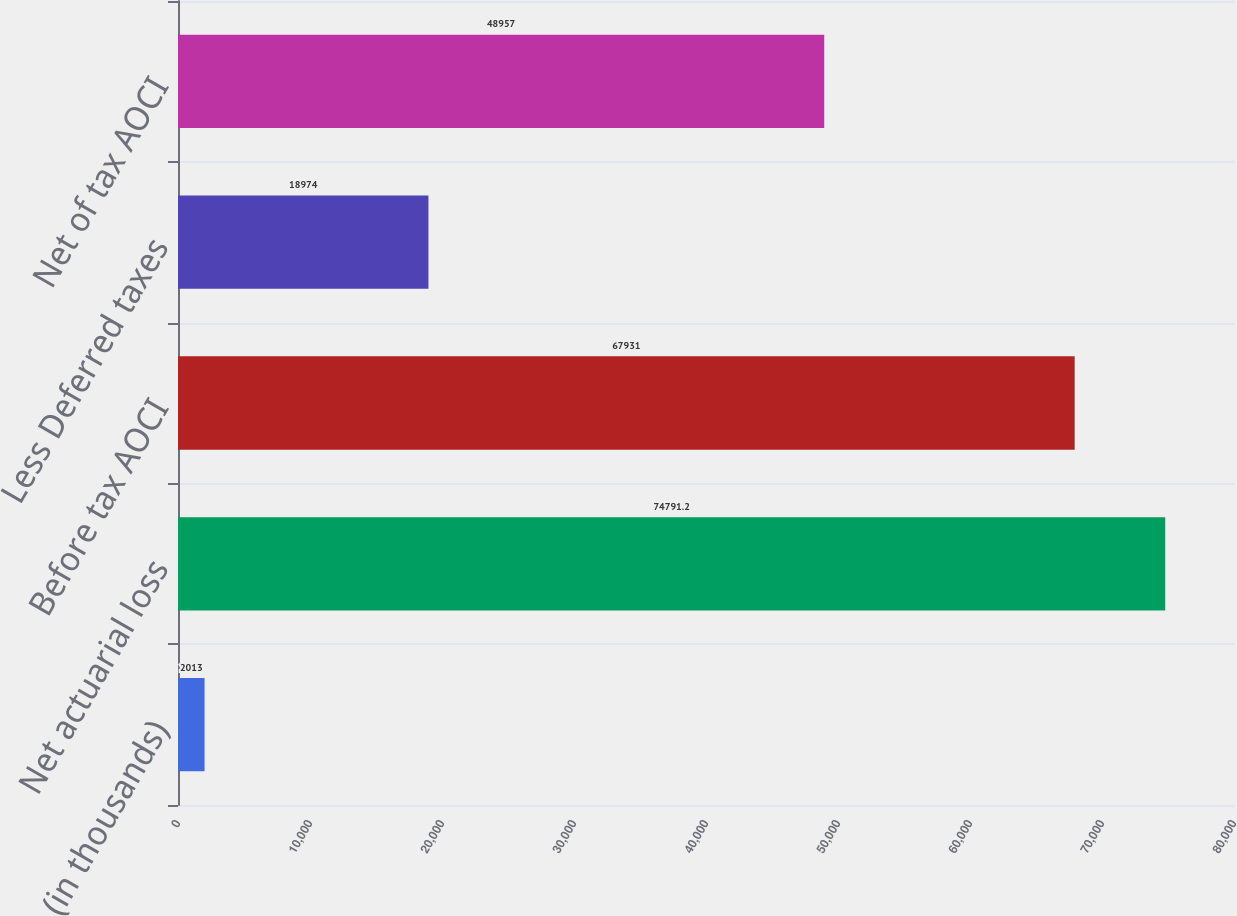Convert chart to OTSL. <chart><loc_0><loc_0><loc_500><loc_500><bar_chart><fcel>(in thousands)<fcel>Net actuarial loss<fcel>Before tax AOCI<fcel>Less Deferred taxes<fcel>Net of tax AOCI<nl><fcel>2013<fcel>74791.2<fcel>67931<fcel>18974<fcel>48957<nl></chart> 